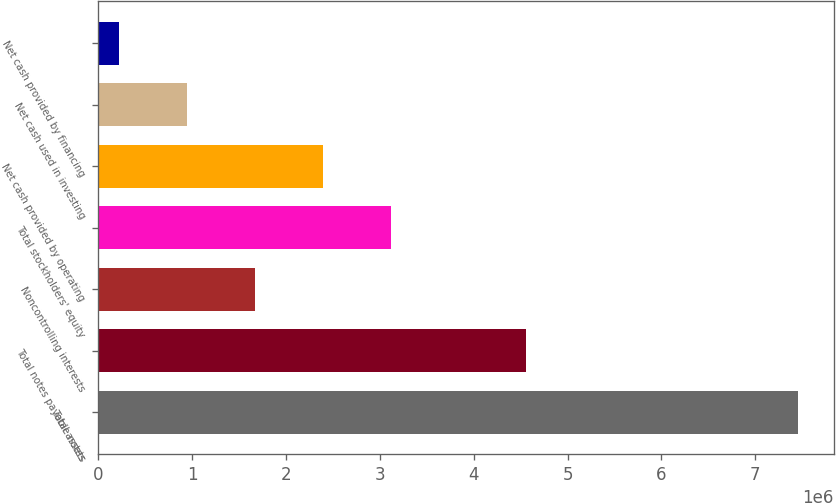<chart> <loc_0><loc_0><loc_500><loc_500><bar_chart><fcel>Total assets<fcel>Total notes payable notes<fcel>Noncontrolling interests<fcel>Total stockholders' equity<fcel>Net cash provided by operating<fcel>Net cash used in investing<fcel>Net cash provided by financing<nl><fcel>7.46095e+06<fcel>4.55422e+06<fcel>1.66499e+06<fcel>3.11398e+06<fcel>2.38948e+06<fcel>940490<fcel>215994<nl></chart> 